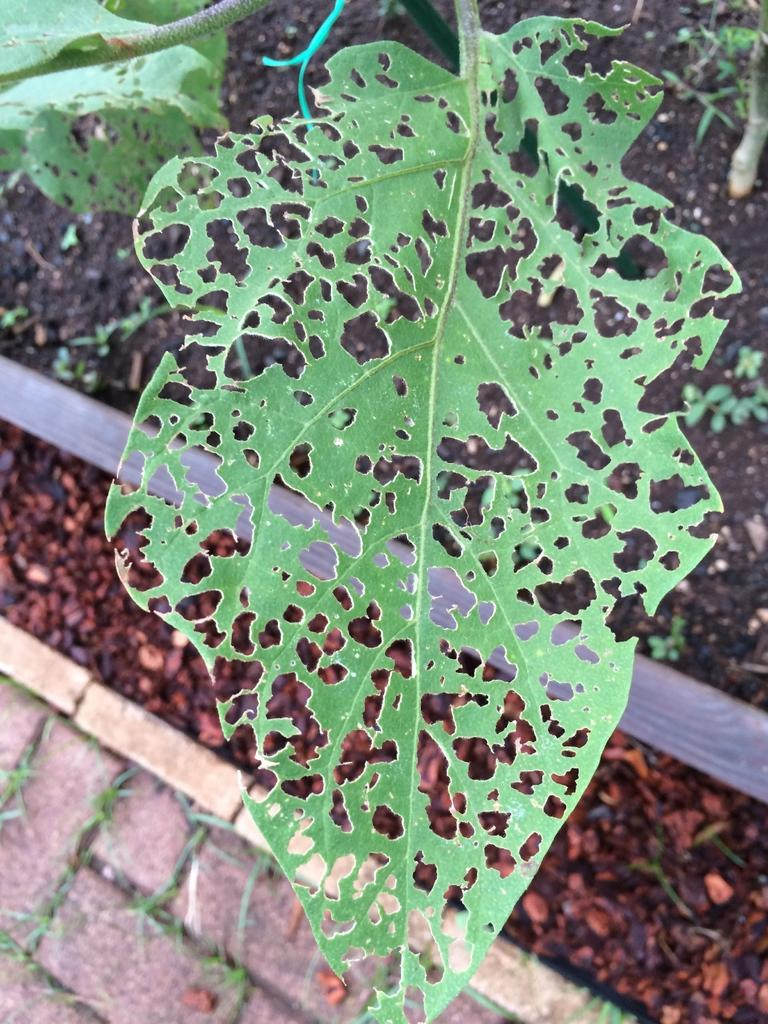What type of vegetation can be seen in the image? There are leaves in the image. What can be found on the ground in the image? Small stones are present on the ground in the image. What type of wound can be seen on the table in the image? There is no table or wound present in the image. What kind of pain is being experienced by the leaves in the image? The leaves in the image are not experiencing any pain, as they are inanimate objects. 